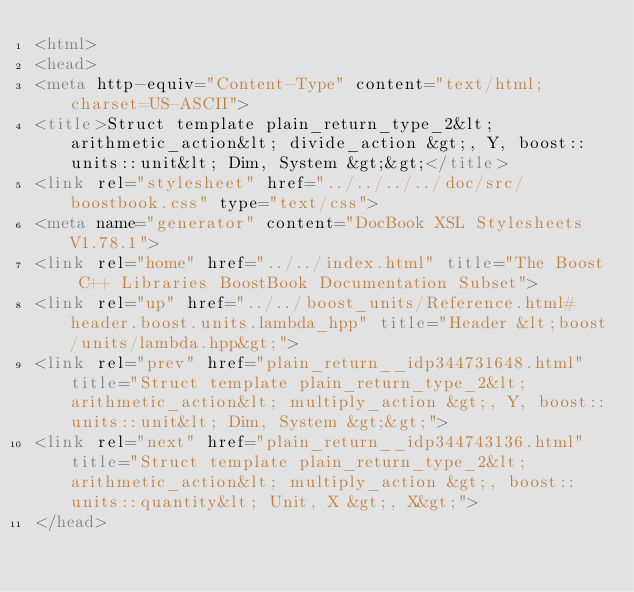Convert code to text. <code><loc_0><loc_0><loc_500><loc_500><_HTML_><html>
<head>
<meta http-equiv="Content-Type" content="text/html; charset=US-ASCII">
<title>Struct template plain_return_type_2&lt;arithmetic_action&lt; divide_action &gt;, Y, boost::units::unit&lt; Dim, System &gt;&gt;</title>
<link rel="stylesheet" href="../../../../doc/src/boostbook.css" type="text/css">
<meta name="generator" content="DocBook XSL Stylesheets V1.78.1">
<link rel="home" href="../../index.html" title="The Boost C++ Libraries BoostBook Documentation Subset">
<link rel="up" href="../../boost_units/Reference.html#header.boost.units.lambda_hpp" title="Header &lt;boost/units/lambda.hpp&gt;">
<link rel="prev" href="plain_return__idp344731648.html" title="Struct template plain_return_type_2&lt;arithmetic_action&lt; multiply_action &gt;, Y, boost::units::unit&lt; Dim, System &gt;&gt;">
<link rel="next" href="plain_return__idp344743136.html" title="Struct template plain_return_type_2&lt;arithmetic_action&lt; multiply_action &gt;, boost::units::quantity&lt; Unit, X &gt;, X&gt;">
</head></code> 